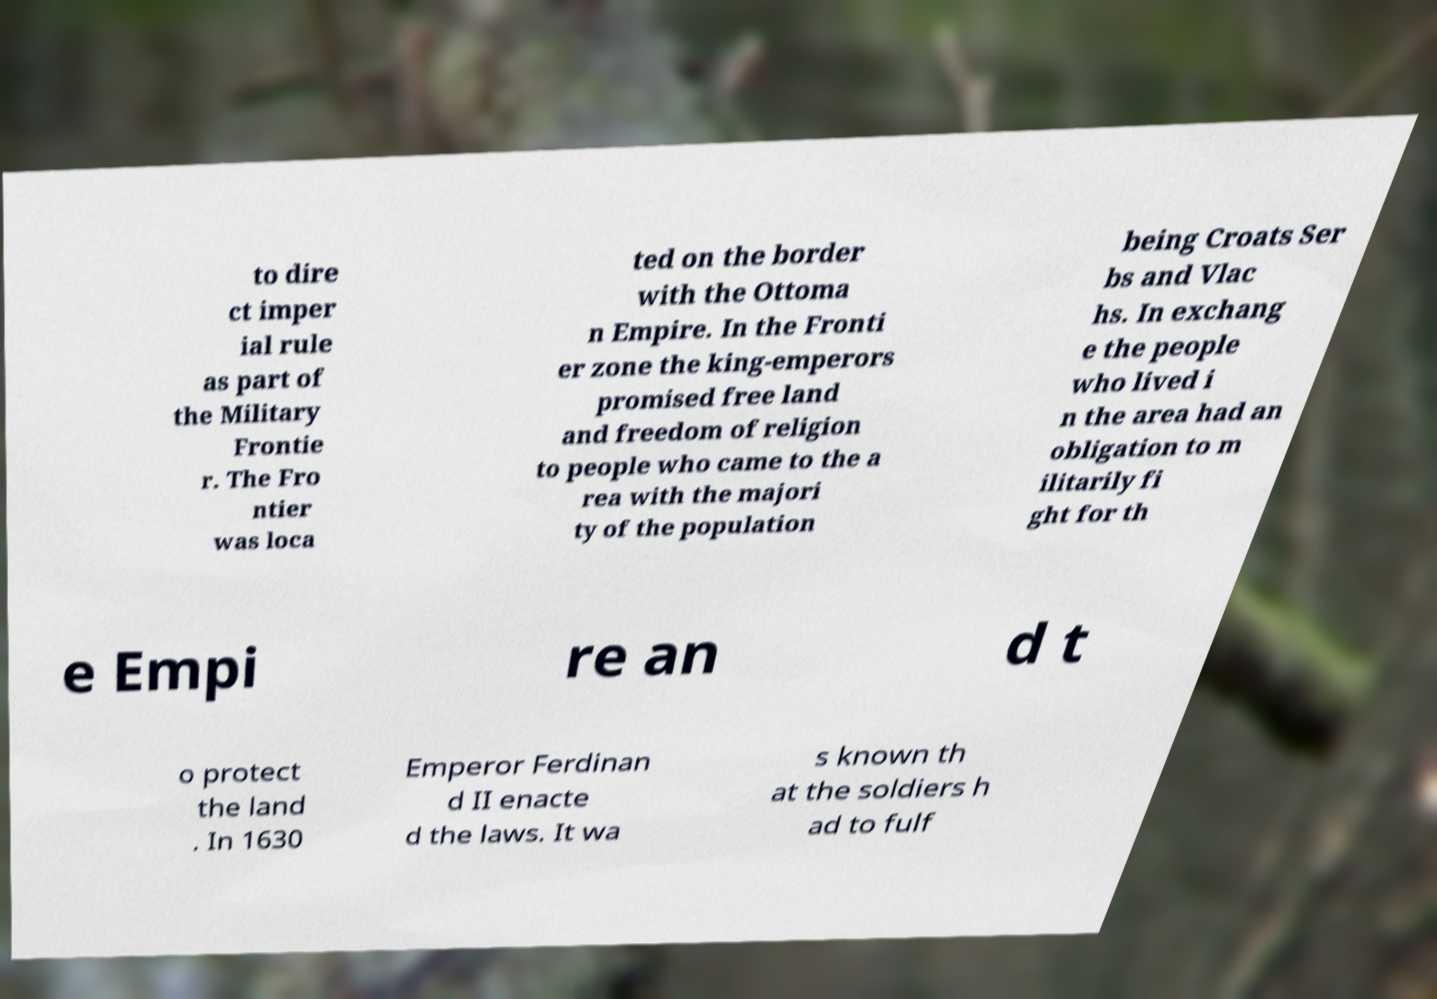I need the written content from this picture converted into text. Can you do that? to dire ct imper ial rule as part of the Military Frontie r. The Fro ntier was loca ted on the border with the Ottoma n Empire. In the Fronti er zone the king-emperors promised free land and freedom of religion to people who came to the a rea with the majori ty of the population being Croats Ser bs and Vlac hs. In exchang e the people who lived i n the area had an obligation to m ilitarily fi ght for th e Empi re an d t o protect the land . In 1630 Emperor Ferdinan d II enacte d the laws. It wa s known th at the soldiers h ad to fulf 